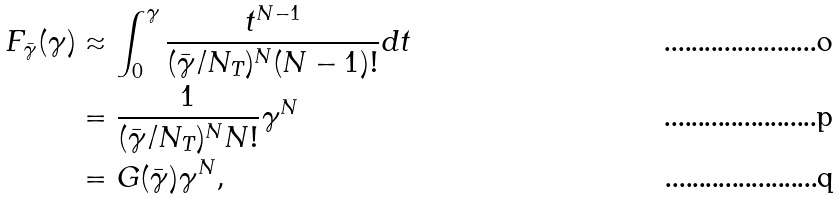<formula> <loc_0><loc_0><loc_500><loc_500>F _ { \bar { \gamma } } ( \gamma ) & \approx \int _ { 0 } ^ { \gamma } \frac { t ^ { N - 1 } } { ( \bar { \gamma } / N _ { T } ) ^ { N } ( N - 1 ) ! } \text {d} t \\ & = \frac { 1 } { ( \bar { \gamma } / N _ { T } ) ^ { N } N ! } \gamma ^ { N } \\ & = G ( \bar { \gamma } ) \gamma ^ { N } ,</formula> 